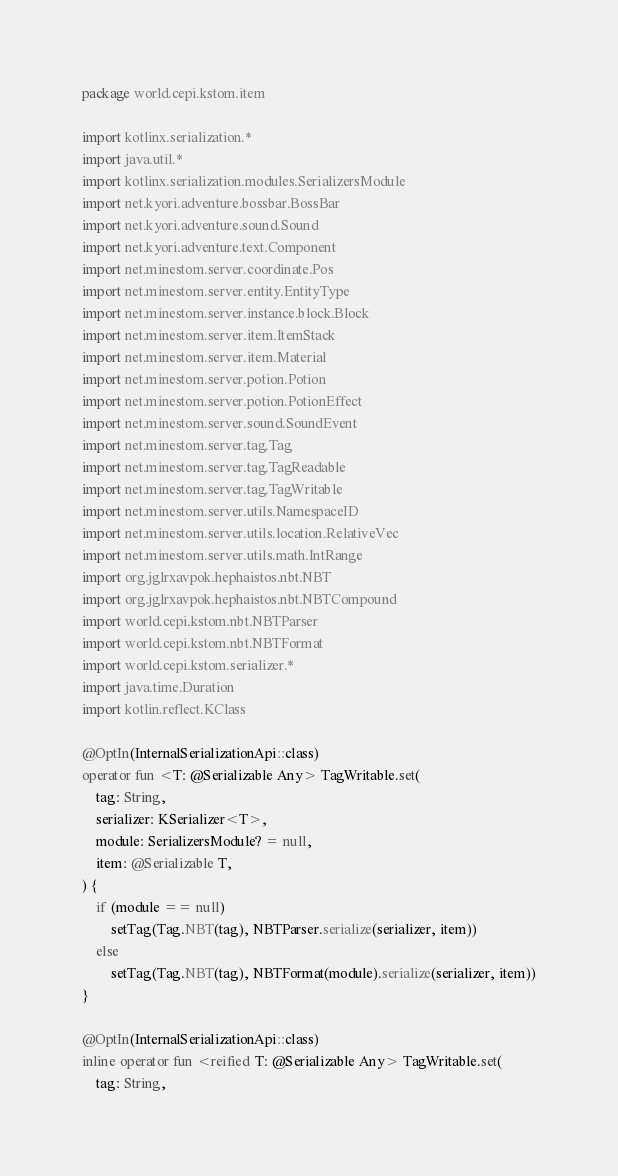Convert code to text. <code><loc_0><loc_0><loc_500><loc_500><_Kotlin_>package world.cepi.kstom.item

import kotlinx.serialization.*
import java.util.*
import kotlinx.serialization.modules.SerializersModule
import net.kyori.adventure.bossbar.BossBar
import net.kyori.adventure.sound.Sound
import net.kyori.adventure.text.Component
import net.minestom.server.coordinate.Pos
import net.minestom.server.entity.EntityType
import net.minestom.server.instance.block.Block
import net.minestom.server.item.ItemStack
import net.minestom.server.item.Material
import net.minestom.server.potion.Potion
import net.minestom.server.potion.PotionEffect
import net.minestom.server.sound.SoundEvent
import net.minestom.server.tag.Tag
import net.minestom.server.tag.TagReadable
import net.minestom.server.tag.TagWritable
import net.minestom.server.utils.NamespaceID
import net.minestom.server.utils.location.RelativeVec
import net.minestom.server.utils.math.IntRange
import org.jglrxavpok.hephaistos.nbt.NBT
import org.jglrxavpok.hephaistos.nbt.NBTCompound
import world.cepi.kstom.nbt.NBTParser
import world.cepi.kstom.nbt.NBTFormat
import world.cepi.kstom.serializer.*
import java.time.Duration
import kotlin.reflect.KClass

@OptIn(InternalSerializationApi::class)
operator fun <T: @Serializable Any> TagWritable.set(
    tag: String,
    serializer: KSerializer<T>,
    module: SerializersModule? = null,
    item: @Serializable T,
) {
    if (module == null)
        setTag(Tag.NBT(tag), NBTParser.serialize(serializer, item))
    else
        setTag(Tag.NBT(tag), NBTFormat(module).serialize(serializer, item))
}

@OptIn(InternalSerializationApi::class)
inline operator fun <reified T: @Serializable Any> TagWritable.set(
    tag: String,</code> 